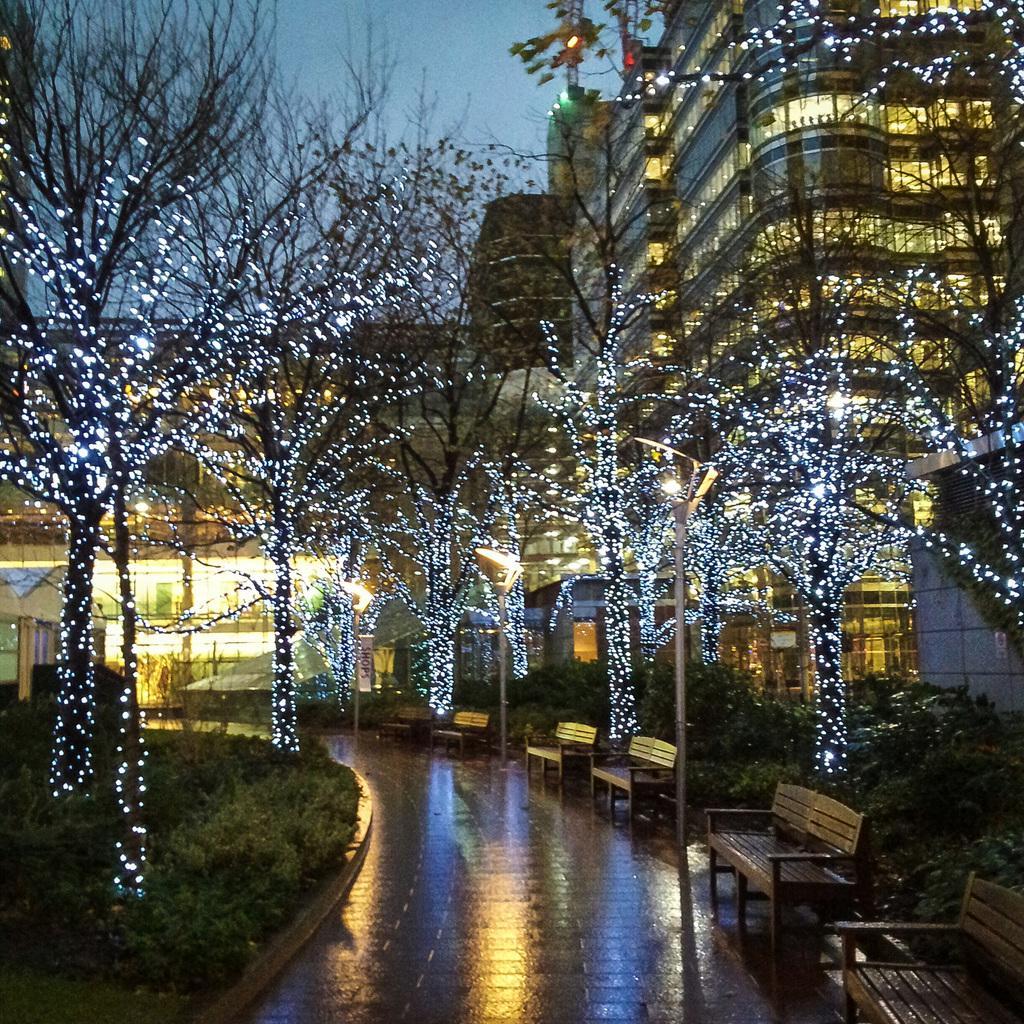Can you describe this image briefly? There are few wooden chairs in the left corner and there are trees decorated with lights on either sides of it and there are buildings in the background. 